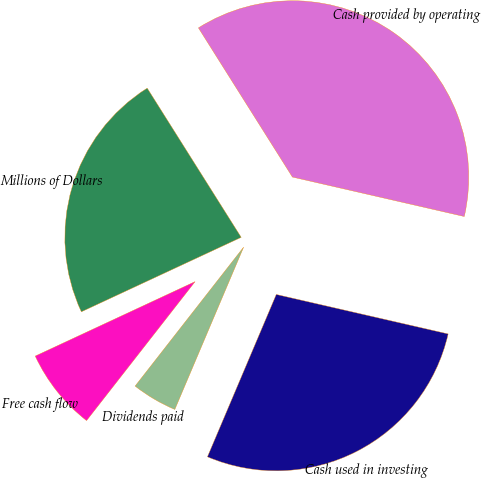Convert chart to OTSL. <chart><loc_0><loc_0><loc_500><loc_500><pie_chart><fcel>Millions of Dollars<fcel>Cash provided by operating<fcel>Cash used in investing<fcel>Dividends paid<fcel>Free cash flow<nl><fcel>22.99%<fcel>37.54%<fcel>27.79%<fcel>4.17%<fcel>7.51%<nl></chart> 